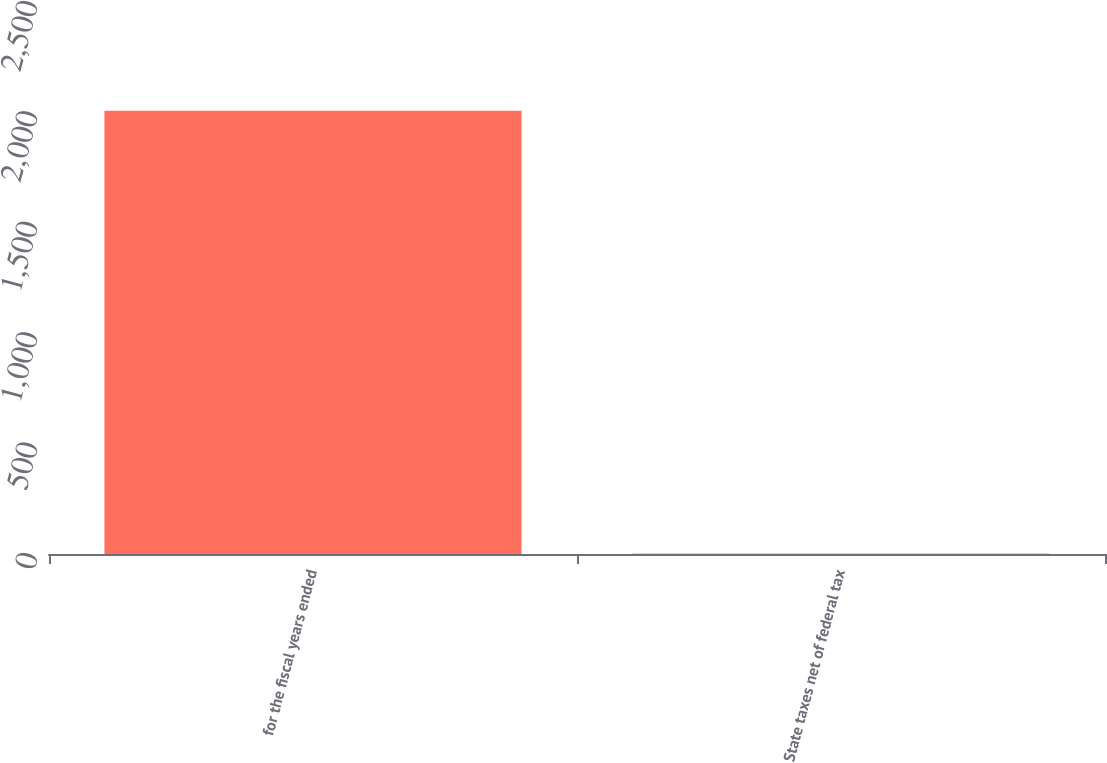<chart> <loc_0><loc_0><loc_500><loc_500><bar_chart><fcel>for the fiscal years ended<fcel>State taxes net of federal tax<nl><fcel>2008<fcel>1.83<nl></chart> 